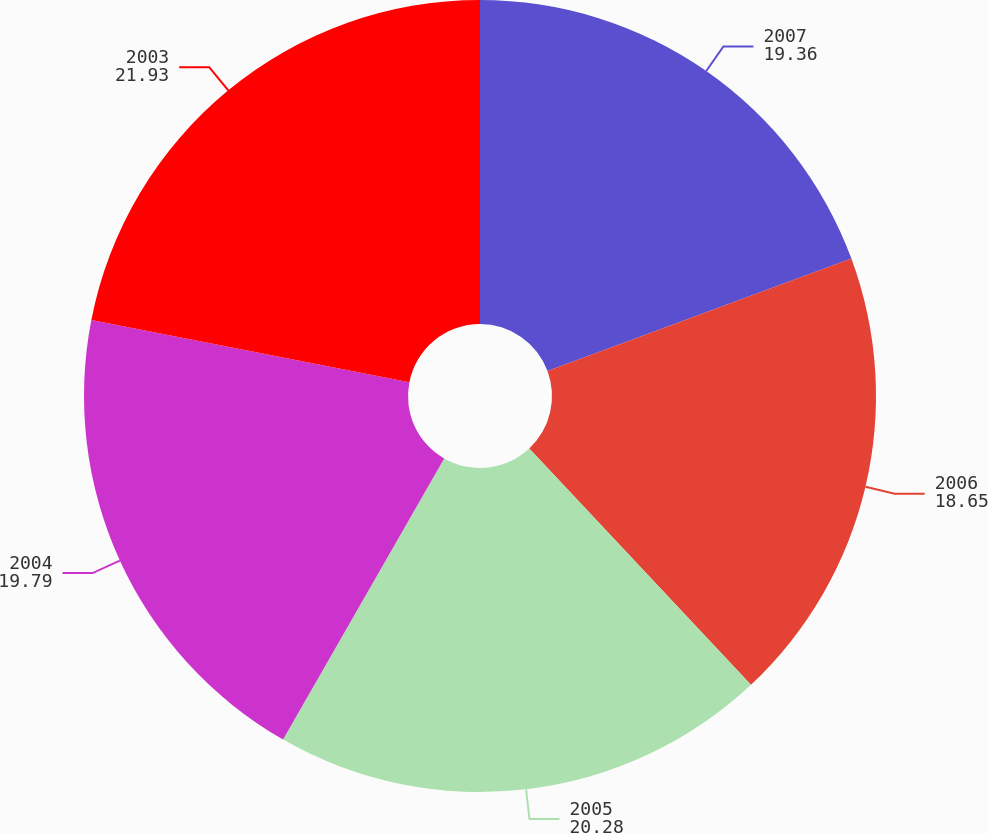Convert chart to OTSL. <chart><loc_0><loc_0><loc_500><loc_500><pie_chart><fcel>2007<fcel>2006<fcel>2005<fcel>2004<fcel>2003<nl><fcel>19.36%<fcel>18.65%<fcel>20.28%<fcel>19.79%<fcel>21.93%<nl></chart> 